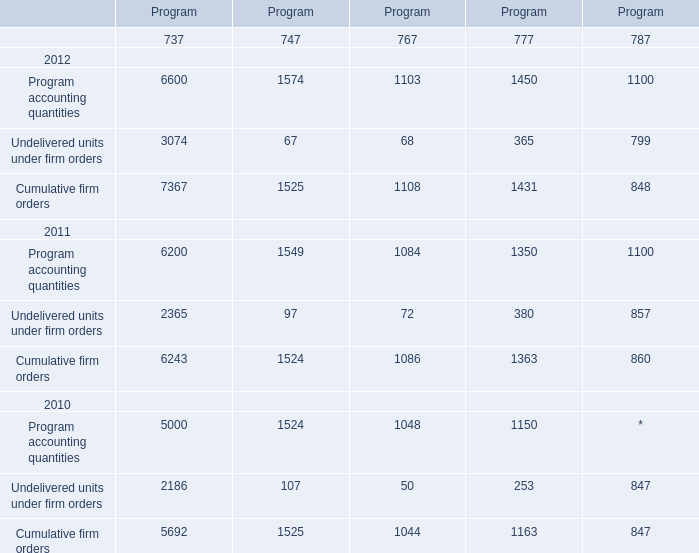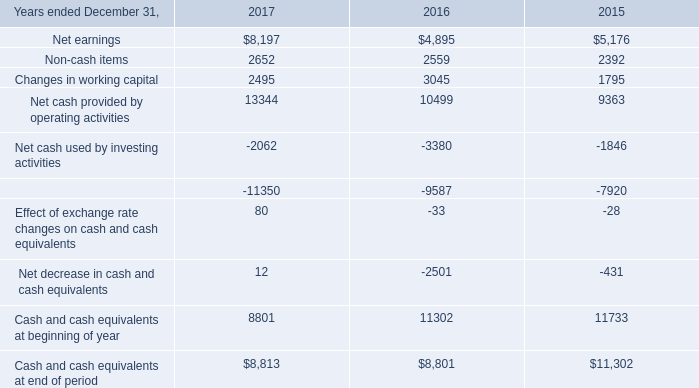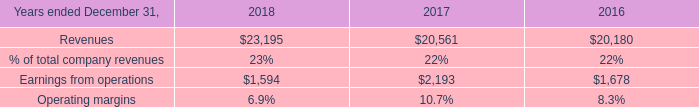What is the sum of Program accounting quantities of 747 in 2011 and Earnings from operations in 2017? 
Computations: (1549 + 2193)
Answer: 3742.0. 